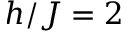Convert formula to latex. <formula><loc_0><loc_0><loc_500><loc_500>h / J = 2</formula> 